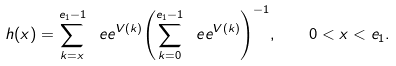<formula> <loc_0><loc_0><loc_500><loc_500>h ( x ) = { \sum _ { k = x } ^ { e _ { 1 } - 1 } \ e e ^ { V ( k ) } } { \left ( \sum _ { k = 0 } ^ { e _ { 1 } - 1 } \ e e ^ { V ( k ) } \right ) ^ { - 1 } } , \quad 0 < x < e _ { 1 } .</formula> 